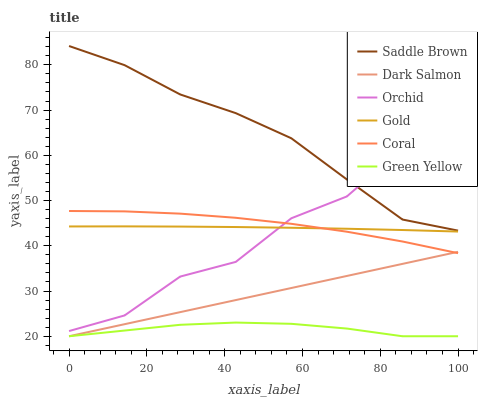Does Green Yellow have the minimum area under the curve?
Answer yes or no. Yes. Does Saddle Brown have the maximum area under the curve?
Answer yes or no. Yes. Does Coral have the minimum area under the curve?
Answer yes or no. No. Does Coral have the maximum area under the curve?
Answer yes or no. No. Is Dark Salmon the smoothest?
Answer yes or no. Yes. Is Orchid the roughest?
Answer yes or no. Yes. Is Coral the smoothest?
Answer yes or no. No. Is Coral the roughest?
Answer yes or no. No. Does Dark Salmon have the lowest value?
Answer yes or no. Yes. Does Coral have the lowest value?
Answer yes or no. No. Does Saddle Brown have the highest value?
Answer yes or no. Yes. Does Coral have the highest value?
Answer yes or no. No. Is Dark Salmon less than Gold?
Answer yes or no. Yes. Is Coral greater than Green Yellow?
Answer yes or no. Yes. Does Saddle Brown intersect Orchid?
Answer yes or no. Yes. Is Saddle Brown less than Orchid?
Answer yes or no. No. Is Saddle Brown greater than Orchid?
Answer yes or no. No. Does Dark Salmon intersect Gold?
Answer yes or no. No. 